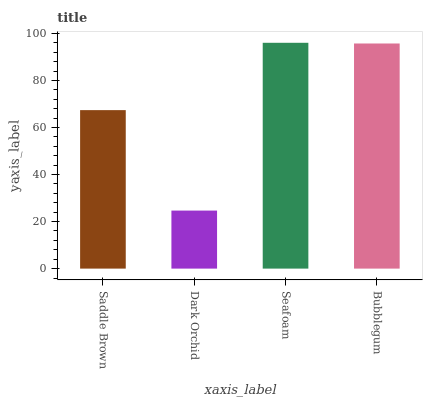Is Dark Orchid the minimum?
Answer yes or no. Yes. Is Seafoam the maximum?
Answer yes or no. Yes. Is Seafoam the minimum?
Answer yes or no. No. Is Dark Orchid the maximum?
Answer yes or no. No. Is Seafoam greater than Dark Orchid?
Answer yes or no. Yes. Is Dark Orchid less than Seafoam?
Answer yes or no. Yes. Is Dark Orchid greater than Seafoam?
Answer yes or no. No. Is Seafoam less than Dark Orchid?
Answer yes or no. No. Is Bubblegum the high median?
Answer yes or no. Yes. Is Saddle Brown the low median?
Answer yes or no. Yes. Is Dark Orchid the high median?
Answer yes or no. No. Is Bubblegum the low median?
Answer yes or no. No. 